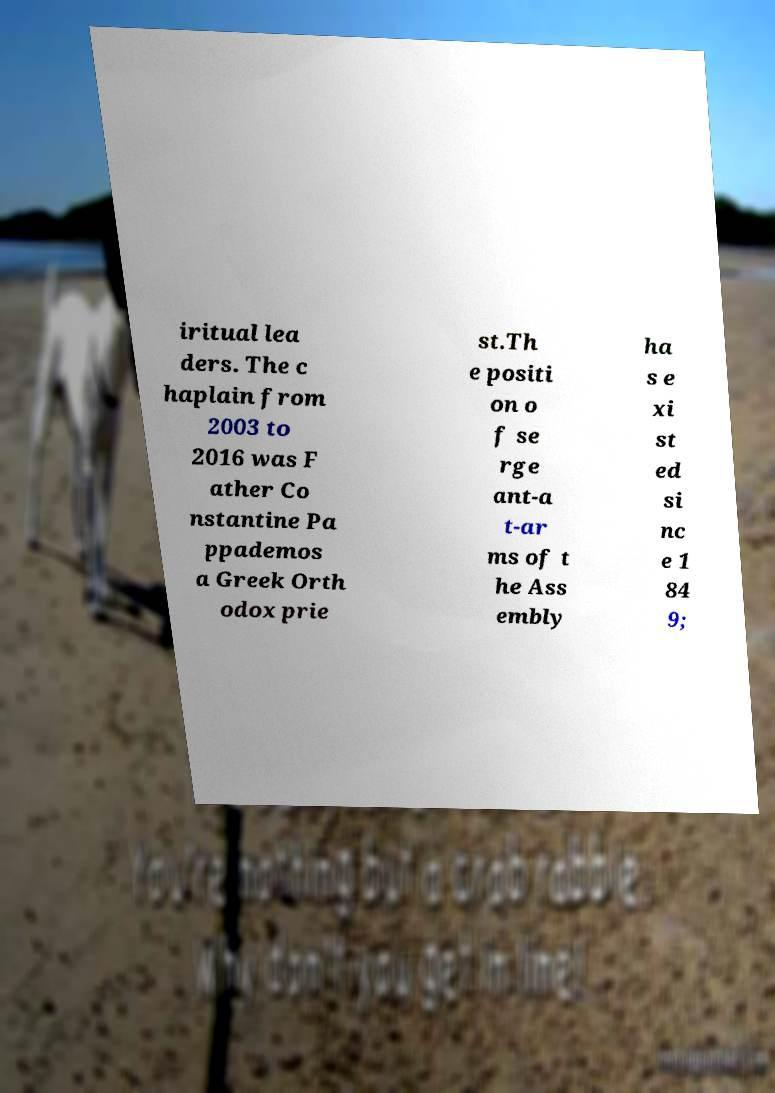I need the written content from this picture converted into text. Can you do that? iritual lea ders. The c haplain from 2003 to 2016 was F ather Co nstantine Pa ppademos a Greek Orth odox prie st.Th e positi on o f se rge ant-a t-ar ms of t he Ass embly ha s e xi st ed si nc e 1 84 9; 